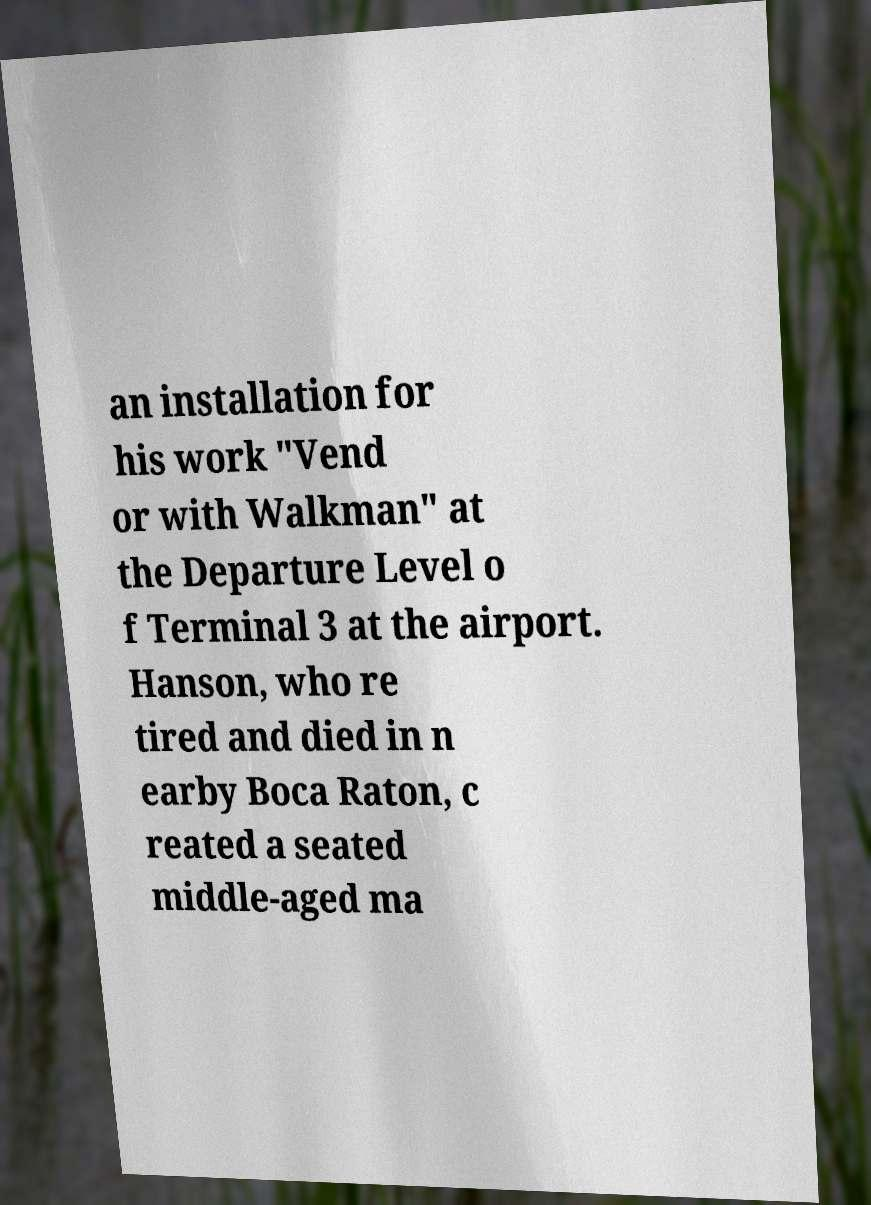Can you accurately transcribe the text from the provided image for me? an installation for his work "Vend or with Walkman" at the Departure Level o f Terminal 3 at the airport. Hanson, who re tired and died in n earby Boca Raton, c reated a seated middle-aged ma 